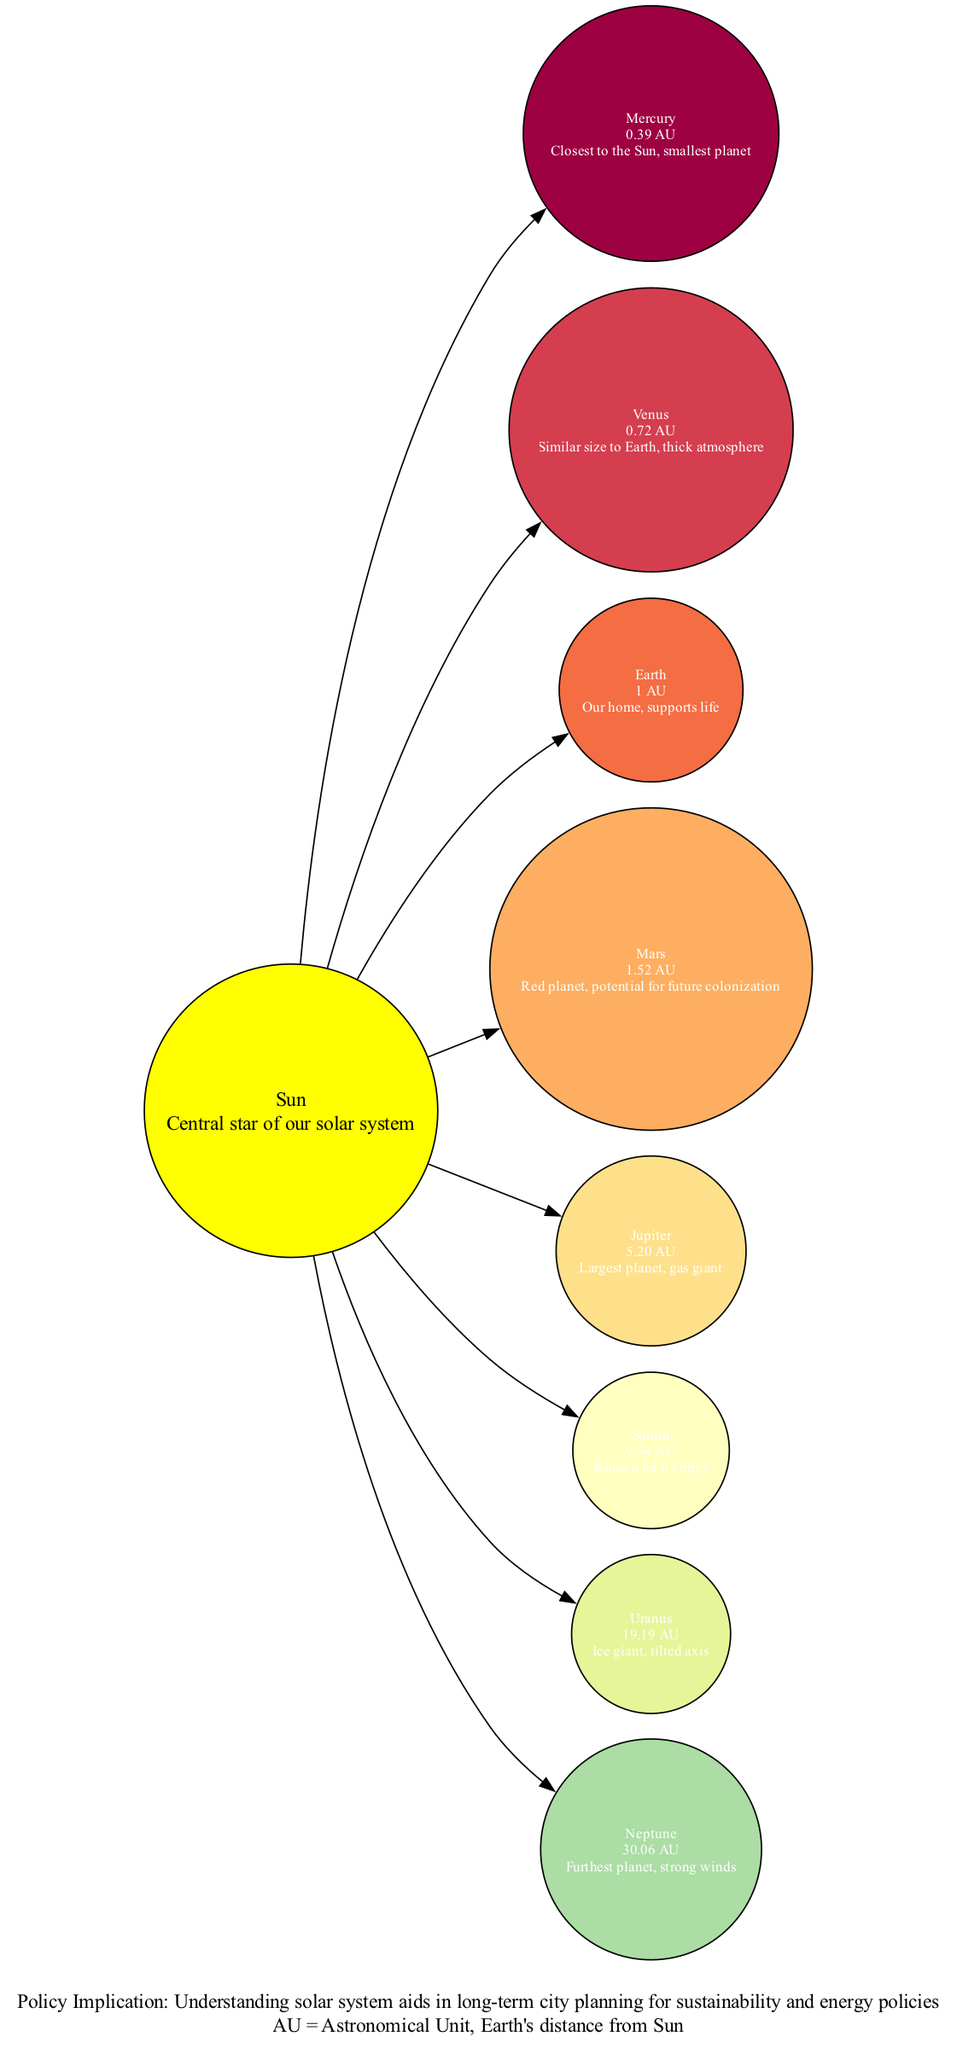What is the distance of Earth from the Sun? The distance of Earth from the Sun is directly labeled in the diagram as "1 AU".
Answer: 1 AU Which planet is the largest in the solar system? The diagram describes Jupiter as "Largest planet, gas giant", indicating that it is the largest planet.
Answer: Jupiter How many planets are labeled in the diagram? There are a total of 8 planets listed in the diagram, indicated by the entries in the "Planets" section.
Answer: 8 Which planet is known for having rings? Looking at the descriptions in the diagram, Saturn is specifically noted for "Known for its rings".
Answer: Saturn What is the average distance of Mercury from the Sun in AU? The diagram explicitly states that Mercury's distance is "0.39 AU", therefore, the answer is taken directly from the diagram.
Answer: 0.39 AU Which is the planet furthest from the Sun? The diagram describes Neptune as the "Furthest planet", indicating it is the one with the greatest distance from the Sun.
Answer: Neptune What type of planet is Uranus categorized as? The diagram states that Uranus is an "Ice giant," which characterizes its type based on its composition and properties.
Answer: Ice giant What is the policy implication stated in the diagram? The last note in the diagram contains the "Policy Implication" as understanding the solar system aids in "long-term city planning for sustainability and energy policies." This provides insight into the broader implications of the information presented.
Answer: Understanding solar system aids in long-term city planning for sustainability and energy policies How many Astronomical Units (AU) away from the Sun is Saturn? The diagram indicates that Saturn is "9.54 AU" away from the Sun, reflecting its distance accurately from the central star.
Answer: 9.54 AU 